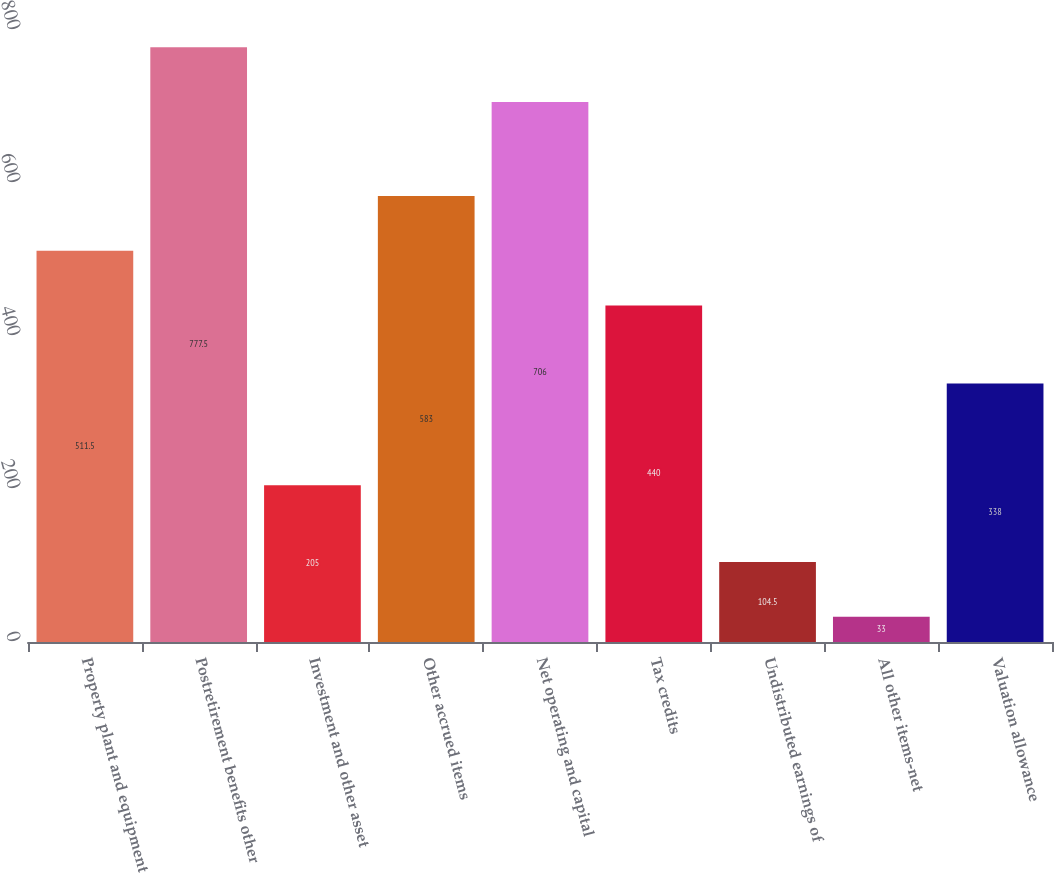Convert chart to OTSL. <chart><loc_0><loc_0><loc_500><loc_500><bar_chart><fcel>Property plant and equipment<fcel>Postretirement benefits other<fcel>Investment and other asset<fcel>Other accrued items<fcel>Net operating and capital<fcel>Tax credits<fcel>Undistributed earnings of<fcel>All other items-net<fcel>Valuation allowance<nl><fcel>511.5<fcel>777.5<fcel>205<fcel>583<fcel>706<fcel>440<fcel>104.5<fcel>33<fcel>338<nl></chart> 